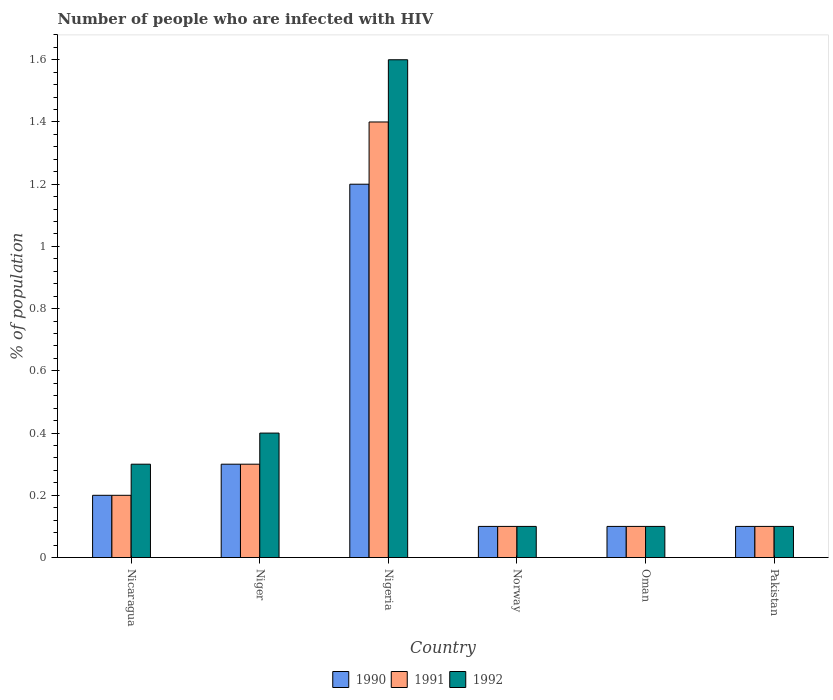How many different coloured bars are there?
Your answer should be compact. 3. Are the number of bars per tick equal to the number of legend labels?
Make the answer very short. Yes. Across all countries, what is the minimum percentage of HIV infected population in in 1991?
Provide a short and direct response. 0.1. In which country was the percentage of HIV infected population in in 1992 maximum?
Ensure brevity in your answer.  Nigeria. In which country was the percentage of HIV infected population in in 1990 minimum?
Ensure brevity in your answer.  Norway. What is the difference between the percentage of HIV infected population in in 1991 in Niger and that in Norway?
Your answer should be compact. 0.2. What is the difference between the percentage of HIV infected population in in 1990 in Nicaragua and the percentage of HIV infected population in in 1992 in Oman?
Keep it short and to the point. 0.1. What is the average percentage of HIV infected population in in 1991 per country?
Your answer should be compact. 0.37. In how many countries, is the percentage of HIV infected population in in 1991 greater than 1.4400000000000002 %?
Provide a short and direct response. 0. What is the ratio of the percentage of HIV infected population in in 1990 in Nigeria to that in Pakistan?
Provide a succinct answer. 12. What is the difference between the highest and the second highest percentage of HIV infected population in in 1990?
Offer a very short reply. -0.9. What is the difference between the highest and the lowest percentage of HIV infected population in in 1990?
Make the answer very short. 1.1. In how many countries, is the percentage of HIV infected population in in 1992 greater than the average percentage of HIV infected population in in 1992 taken over all countries?
Provide a succinct answer. 1. What does the 1st bar from the left in Oman represents?
Give a very brief answer. 1990. Is it the case that in every country, the sum of the percentage of HIV infected population in in 1991 and percentage of HIV infected population in in 1992 is greater than the percentage of HIV infected population in in 1990?
Provide a short and direct response. Yes. How many countries are there in the graph?
Your response must be concise. 6. What is the difference between two consecutive major ticks on the Y-axis?
Offer a very short reply. 0.2. Does the graph contain any zero values?
Offer a very short reply. No. Does the graph contain grids?
Provide a succinct answer. No. How are the legend labels stacked?
Offer a terse response. Horizontal. What is the title of the graph?
Give a very brief answer. Number of people who are infected with HIV. Does "2003" appear as one of the legend labels in the graph?
Your answer should be compact. No. What is the label or title of the Y-axis?
Give a very brief answer. % of population. What is the % of population in 1990 in Nicaragua?
Make the answer very short. 0.2. What is the % of population in 1992 in Nicaragua?
Offer a terse response. 0.3. What is the % of population in 1992 in Niger?
Your answer should be compact. 0.4. What is the % of population in 1992 in Nigeria?
Ensure brevity in your answer.  1.6. What is the % of population of 1991 in Norway?
Provide a succinct answer. 0.1. What is the % of population in 1992 in Norway?
Ensure brevity in your answer.  0.1. What is the % of population of 1991 in Oman?
Your answer should be very brief. 0.1. What is the % of population of 1990 in Pakistan?
Your response must be concise. 0.1. Across all countries, what is the minimum % of population of 1990?
Keep it short and to the point. 0.1. Across all countries, what is the minimum % of population in 1991?
Provide a succinct answer. 0.1. Across all countries, what is the minimum % of population of 1992?
Give a very brief answer. 0.1. What is the total % of population of 1991 in the graph?
Keep it short and to the point. 2.2. What is the total % of population of 1992 in the graph?
Make the answer very short. 2.6. What is the difference between the % of population in 1990 in Nicaragua and that in Niger?
Your answer should be very brief. -0.1. What is the difference between the % of population in 1991 in Nicaragua and that in Nigeria?
Offer a very short reply. -1.2. What is the difference between the % of population of 1992 in Nicaragua and that in Nigeria?
Ensure brevity in your answer.  -1.3. What is the difference between the % of population in 1992 in Nicaragua and that in Norway?
Provide a succinct answer. 0.2. What is the difference between the % of population of 1992 in Nicaragua and that in Oman?
Your response must be concise. 0.2. What is the difference between the % of population of 1991 in Nicaragua and that in Pakistan?
Provide a succinct answer. 0.1. What is the difference between the % of population of 1991 in Niger and that in Nigeria?
Keep it short and to the point. -1.1. What is the difference between the % of population in 1992 in Niger and that in Norway?
Keep it short and to the point. 0.3. What is the difference between the % of population of 1991 in Niger and that in Pakistan?
Ensure brevity in your answer.  0.2. What is the difference between the % of population of 1991 in Nigeria and that in Norway?
Provide a succinct answer. 1.3. What is the difference between the % of population of 1990 in Nigeria and that in Oman?
Offer a very short reply. 1.1. What is the difference between the % of population of 1991 in Nigeria and that in Oman?
Make the answer very short. 1.3. What is the difference between the % of population of 1992 in Nigeria and that in Oman?
Your answer should be compact. 1.5. What is the difference between the % of population in 1991 in Norway and that in Oman?
Your response must be concise. 0. What is the difference between the % of population in 1992 in Norway and that in Pakistan?
Offer a very short reply. 0. What is the difference between the % of population of 1990 in Oman and that in Pakistan?
Your answer should be compact. 0. What is the difference between the % of population in 1991 in Oman and that in Pakistan?
Your response must be concise. 0. What is the difference between the % of population in 1990 in Nicaragua and the % of population in 1991 in Niger?
Your answer should be very brief. -0.1. What is the difference between the % of population of 1990 in Nicaragua and the % of population of 1992 in Niger?
Keep it short and to the point. -0.2. What is the difference between the % of population in 1990 in Nicaragua and the % of population in 1992 in Norway?
Your answer should be compact. 0.1. What is the difference between the % of population in 1990 in Nicaragua and the % of population in 1991 in Oman?
Provide a succinct answer. 0.1. What is the difference between the % of population of 1991 in Nicaragua and the % of population of 1992 in Oman?
Offer a terse response. 0.1. What is the difference between the % of population of 1991 in Nicaragua and the % of population of 1992 in Pakistan?
Provide a succinct answer. 0.1. What is the difference between the % of population in 1990 in Niger and the % of population in 1992 in Nigeria?
Your answer should be compact. -1.3. What is the difference between the % of population of 1991 in Niger and the % of population of 1992 in Nigeria?
Provide a short and direct response. -1.3. What is the difference between the % of population of 1990 in Niger and the % of population of 1992 in Norway?
Ensure brevity in your answer.  0.2. What is the difference between the % of population of 1991 in Niger and the % of population of 1992 in Norway?
Provide a short and direct response. 0.2. What is the difference between the % of population of 1990 in Niger and the % of population of 1991 in Oman?
Offer a very short reply. 0.2. What is the difference between the % of population in 1990 in Niger and the % of population in 1991 in Pakistan?
Offer a very short reply. 0.2. What is the difference between the % of population of 1990 in Niger and the % of population of 1992 in Pakistan?
Provide a succinct answer. 0.2. What is the difference between the % of population of 1990 in Nigeria and the % of population of 1991 in Norway?
Your response must be concise. 1.1. What is the difference between the % of population of 1990 in Nigeria and the % of population of 1992 in Norway?
Keep it short and to the point. 1.1. What is the difference between the % of population of 1991 in Nigeria and the % of population of 1992 in Norway?
Provide a succinct answer. 1.3. What is the difference between the % of population of 1990 in Nigeria and the % of population of 1991 in Oman?
Give a very brief answer. 1.1. What is the difference between the % of population in 1990 in Nigeria and the % of population in 1992 in Oman?
Provide a short and direct response. 1.1. What is the difference between the % of population of 1990 in Nigeria and the % of population of 1992 in Pakistan?
Your response must be concise. 1.1. What is the difference between the % of population of 1991 in Norway and the % of population of 1992 in Oman?
Offer a very short reply. 0. What is the difference between the % of population of 1990 in Norway and the % of population of 1992 in Pakistan?
Provide a short and direct response. 0. What is the difference between the % of population of 1991 in Oman and the % of population of 1992 in Pakistan?
Offer a very short reply. 0. What is the average % of population in 1990 per country?
Make the answer very short. 0.33. What is the average % of population of 1991 per country?
Provide a succinct answer. 0.37. What is the average % of population of 1992 per country?
Keep it short and to the point. 0.43. What is the difference between the % of population of 1990 and % of population of 1991 in Nicaragua?
Offer a terse response. 0. What is the difference between the % of population of 1990 and % of population of 1991 in Niger?
Give a very brief answer. 0. What is the difference between the % of population of 1991 and % of population of 1992 in Niger?
Make the answer very short. -0.1. What is the difference between the % of population of 1990 and % of population of 1991 in Nigeria?
Make the answer very short. -0.2. What is the difference between the % of population in 1990 and % of population in 1992 in Nigeria?
Offer a terse response. -0.4. What is the difference between the % of population in 1991 and % of population in 1992 in Nigeria?
Your response must be concise. -0.2. What is the difference between the % of population in 1990 and % of population in 1992 in Oman?
Your answer should be very brief. 0. What is the difference between the % of population of 1991 and % of population of 1992 in Oman?
Ensure brevity in your answer.  0. What is the ratio of the % of population in 1990 in Nicaragua to that in Niger?
Offer a very short reply. 0.67. What is the ratio of the % of population of 1991 in Nicaragua to that in Niger?
Make the answer very short. 0.67. What is the ratio of the % of population in 1991 in Nicaragua to that in Nigeria?
Provide a short and direct response. 0.14. What is the ratio of the % of population of 1992 in Nicaragua to that in Nigeria?
Provide a succinct answer. 0.19. What is the ratio of the % of population in 1991 in Nicaragua to that in Norway?
Your answer should be very brief. 2. What is the ratio of the % of population of 1990 in Nicaragua to that in Oman?
Your answer should be very brief. 2. What is the ratio of the % of population of 1991 in Nicaragua to that in Oman?
Your answer should be very brief. 2. What is the ratio of the % of population in 1992 in Nicaragua to that in Oman?
Provide a short and direct response. 3. What is the ratio of the % of population in 1992 in Nicaragua to that in Pakistan?
Offer a terse response. 3. What is the ratio of the % of population in 1990 in Niger to that in Nigeria?
Ensure brevity in your answer.  0.25. What is the ratio of the % of population of 1991 in Niger to that in Nigeria?
Keep it short and to the point. 0.21. What is the ratio of the % of population in 1992 in Niger to that in Nigeria?
Ensure brevity in your answer.  0.25. What is the ratio of the % of population in 1990 in Niger to that in Norway?
Ensure brevity in your answer.  3. What is the ratio of the % of population of 1991 in Niger to that in Norway?
Your response must be concise. 3. What is the ratio of the % of population in 1990 in Niger to that in Oman?
Ensure brevity in your answer.  3. What is the ratio of the % of population of 1991 in Niger to that in Oman?
Provide a succinct answer. 3. What is the ratio of the % of population in 1990 in Niger to that in Pakistan?
Your response must be concise. 3. What is the ratio of the % of population of 1991 in Niger to that in Pakistan?
Ensure brevity in your answer.  3. What is the ratio of the % of population in 1992 in Nigeria to that in Norway?
Offer a very short reply. 16. What is the ratio of the % of population in 1990 in Nigeria to that in Oman?
Ensure brevity in your answer.  12. What is the ratio of the % of population in 1992 in Nigeria to that in Oman?
Offer a very short reply. 16. What is the ratio of the % of population of 1991 in Nigeria to that in Pakistan?
Provide a succinct answer. 14. What is the ratio of the % of population in 1992 in Nigeria to that in Pakistan?
Give a very brief answer. 16. What is the ratio of the % of population of 1991 in Norway to that in Oman?
Provide a succinct answer. 1. What is the ratio of the % of population of 1990 in Norway to that in Pakistan?
Provide a short and direct response. 1. What is the ratio of the % of population in 1991 in Norway to that in Pakistan?
Provide a short and direct response. 1. What is the ratio of the % of population in 1992 in Norway to that in Pakistan?
Your answer should be compact. 1. What is the ratio of the % of population of 1991 in Oman to that in Pakistan?
Offer a very short reply. 1. What is the ratio of the % of population of 1992 in Oman to that in Pakistan?
Give a very brief answer. 1. What is the difference between the highest and the lowest % of population in 1990?
Ensure brevity in your answer.  1.1. What is the difference between the highest and the lowest % of population in 1991?
Offer a very short reply. 1.3. 